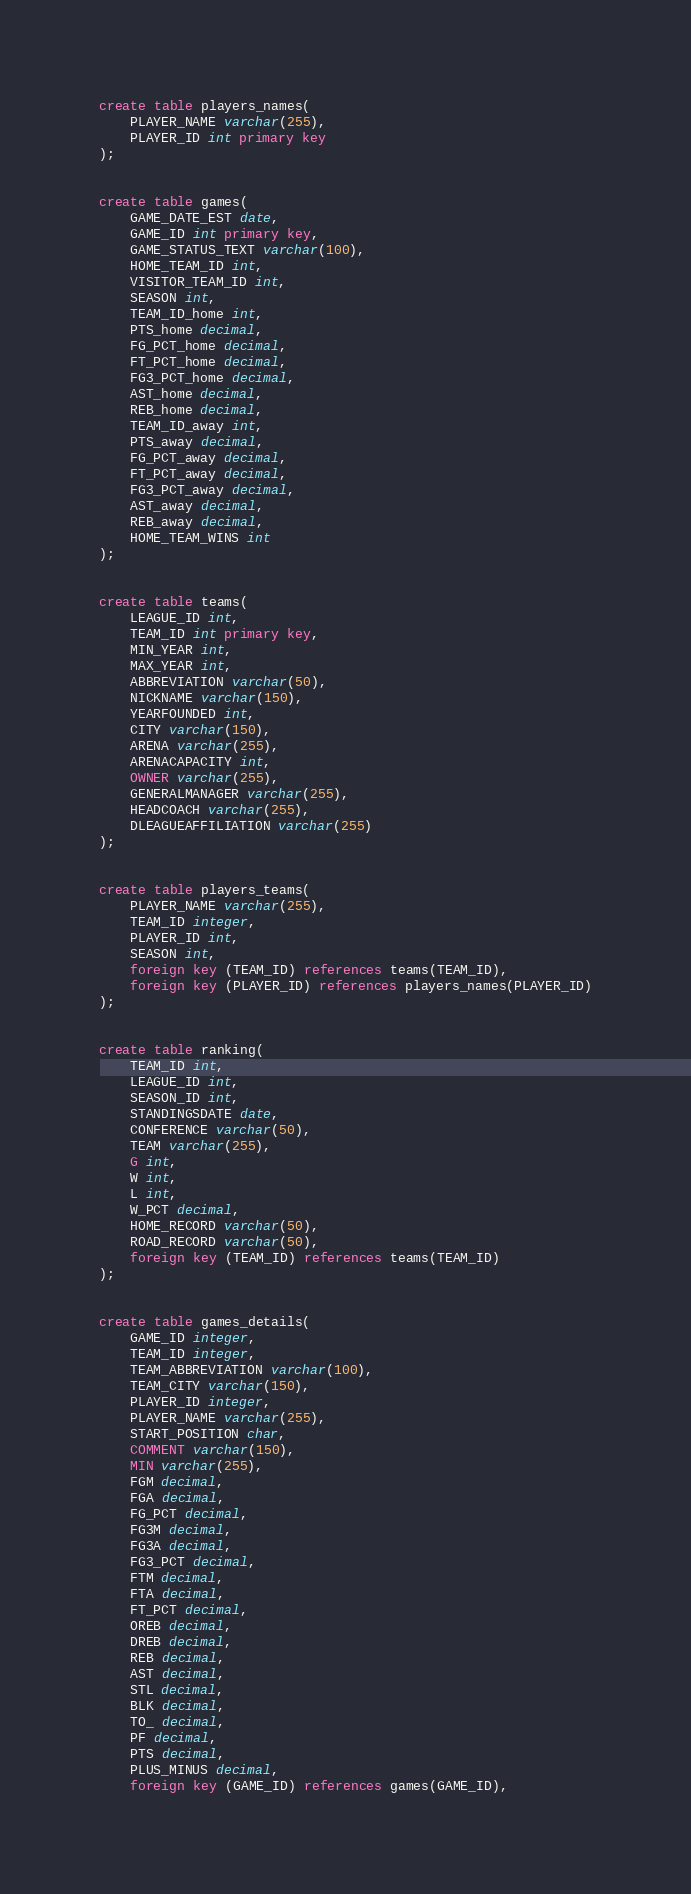Convert code to text. <code><loc_0><loc_0><loc_500><loc_500><_SQL_>create table players_names(
	PLAYER_NAME varchar(255),
	PLAYER_ID int primary key
);


create table games(
	GAME_DATE_EST date,
	GAME_ID int primary key,
	GAME_STATUS_TEXT varchar(100),
	HOME_TEAM_ID int,
	VISITOR_TEAM_ID int, 
	SEASON int, 
	TEAM_ID_home int,
	PTS_home decimal,
	FG_PCT_home decimal,
	FT_PCT_home decimal, 
	FG3_PCT_home decimal, 
	AST_home decimal,
	REB_home decimal,
	TEAM_ID_away int,
	PTS_away decimal,
	FG_PCT_away decimal, 
	FT_PCT_away decimal,
	FG3_PCT_away decimal,
	AST_away decimal,
	REB_away decimal, 
	HOME_TEAM_WINS int
);


create table teams(
	LEAGUE_ID int,
	TEAM_ID int primary key,
	MIN_YEAR int, 
	MAX_YEAR int, 
	ABBREVIATION varchar(50),
	NICKNAME varchar(150),
	YEARFOUNDED int,
	CITY varchar(150),
	ARENA varchar(255),
	ARENACAPACITY int,
	OWNER varchar(255),
	GENERALMANAGER varchar(255),
	HEADCOACH varchar(255),
	DLEAGUEAFFILIATION varchar(255)
);


create table players_teams(
	PLAYER_NAME varchar(255),
	TEAM_ID integer, 
	PLAYER_ID int, 
	SEASON int,
	foreign key (TEAM_ID) references teams(TEAM_ID),
	foreign key (PLAYER_ID) references players_names(PLAYER_ID)
);


create table ranking(
	TEAM_ID int,
	LEAGUE_ID int, 
	SEASON_ID int, 
	STANDINGSDATE date,
	CONFERENCE varchar(50),
	TEAM varchar(255),
	G int,
	W int,
	L int, 
	W_PCT decimal,
	HOME_RECORD varchar(50),
	ROAD_RECORD varchar(50),
	foreign key (TEAM_ID) references teams(TEAM_ID)
);


create table games_details(
	GAME_ID integer, 
	TEAM_ID integer, 
	TEAM_ABBREVIATION varchar(100),
	TEAM_CITY varchar(150),
	PLAYER_ID integer, 
	PLAYER_NAME varchar(255),
	START_POSITION char,
	COMMENT varchar(150),
	MIN varchar(255),
	FGM decimal,
	FGA decimal,
	FG_PCT decimal,
	FG3M decimal,
	FG3A decimal,
	FG3_PCT decimal,
	FTM decimal,
	FTA decimal, 
	FT_PCT decimal,
	OREB decimal, 
	DREB decimal,
	REB decimal,
	AST decimal,
	STL decimal, 
	BLK decimal, 
	TO_ decimal,
	PF decimal,
	PTS decimal,
	PLUS_MINUS decimal,
	foreign key (GAME_ID) references games(GAME_ID),</code> 